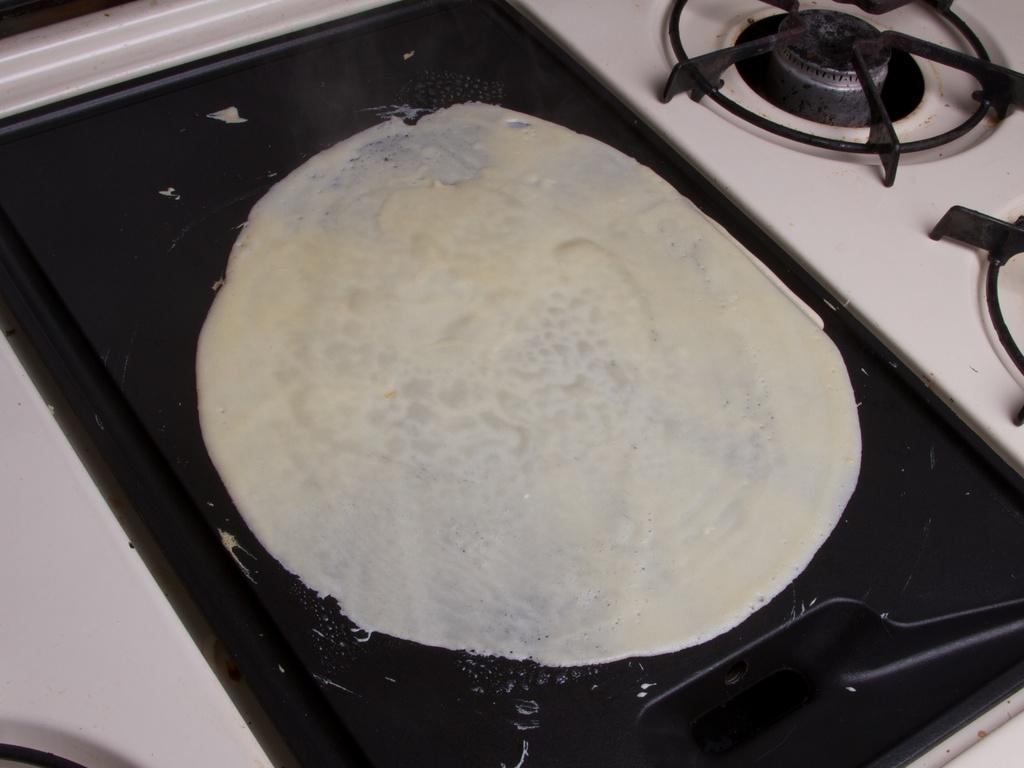What is the main subject of the image? The main subject of the image is pancake dough. Where is the pancake dough located in the image? The pancake dough is on a gas stove. Can you see a friend helping to cook the pancakes in the image? There is no friend present in the image; it only shows pancake dough on a gas stove. Is the sea visible in the background of the image? The image does not show any sea or background; it only shows pancake dough on a gas stove. 